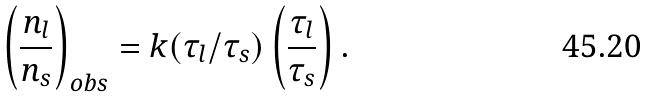<formula> <loc_0><loc_0><loc_500><loc_500>\left ( \frac { n _ { l } } { n _ { s } } \right ) _ { o b s } = k ( \tau _ { l } / \tau _ { s } ) \left ( \frac { \tau _ { l } } { \tau _ { s } } \right ) .</formula> 